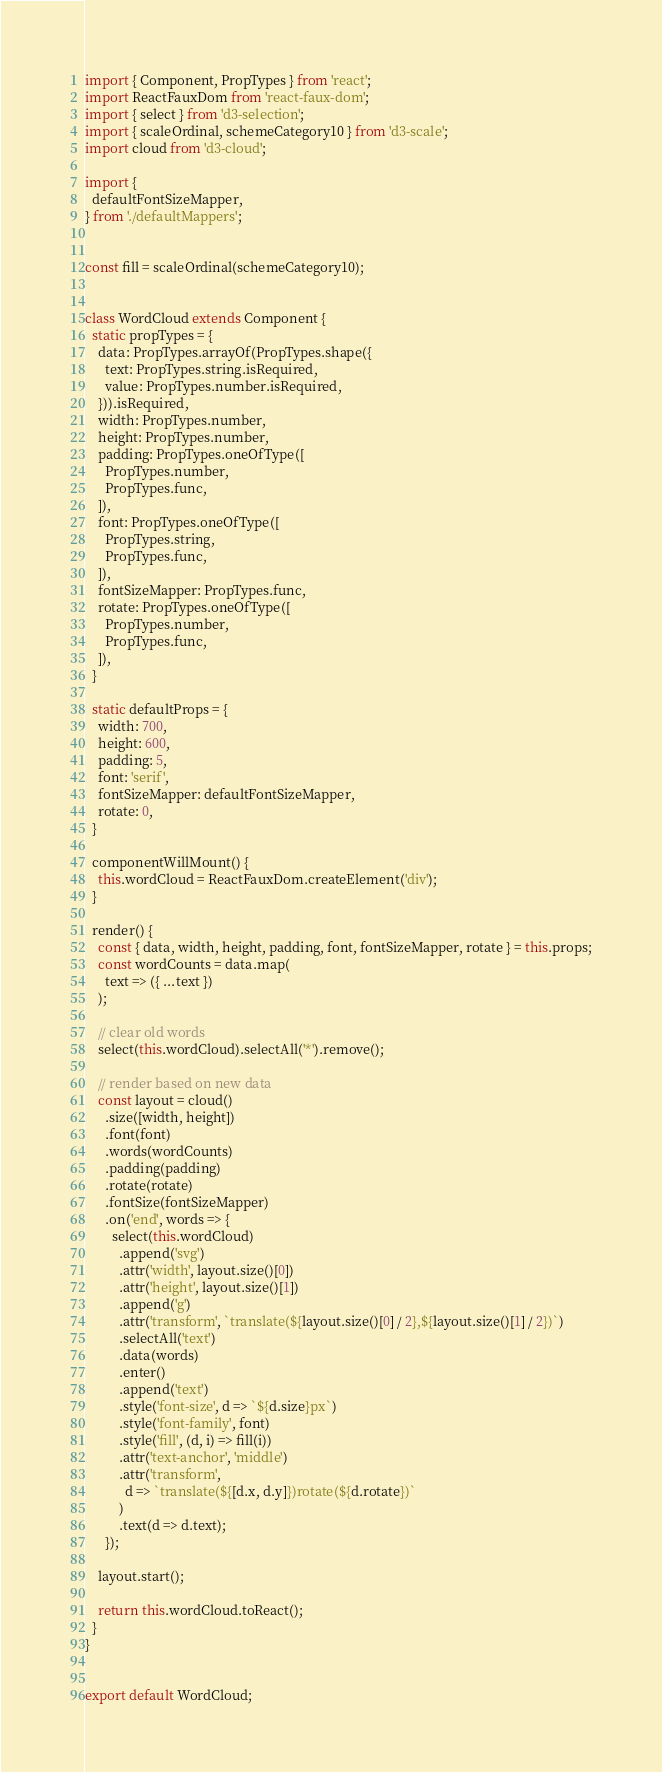<code> <loc_0><loc_0><loc_500><loc_500><_JavaScript_>import { Component, PropTypes } from 'react';
import ReactFauxDom from 'react-faux-dom';
import { select } from 'd3-selection';
import { scaleOrdinal, schemeCategory10 } from 'd3-scale';
import cloud from 'd3-cloud';

import {
  defaultFontSizeMapper,
} from './defaultMappers';


const fill = scaleOrdinal(schemeCategory10);


class WordCloud extends Component {
  static propTypes = {
    data: PropTypes.arrayOf(PropTypes.shape({
      text: PropTypes.string.isRequired,
      value: PropTypes.number.isRequired,
    })).isRequired,
    width: PropTypes.number,
    height: PropTypes.number,
    padding: PropTypes.oneOfType([
      PropTypes.number,
      PropTypes.func,
    ]),
    font: PropTypes.oneOfType([
      PropTypes.string,
      PropTypes.func,
    ]),
    fontSizeMapper: PropTypes.func,
    rotate: PropTypes.oneOfType([
      PropTypes.number,
      PropTypes.func,
    ]),
  }

  static defaultProps = {
    width: 700,
    height: 600,
    padding: 5,
    font: 'serif',
    fontSizeMapper: defaultFontSizeMapper,
    rotate: 0,
  }

  componentWillMount() {
    this.wordCloud = ReactFauxDom.createElement('div');
  }

  render() {
    const { data, width, height, padding, font, fontSizeMapper, rotate } = this.props;
    const wordCounts = data.map(
      text => ({ ...text })
    );

    // clear old words
    select(this.wordCloud).selectAll('*').remove();

    // render based on new data
    const layout = cloud()
      .size([width, height])
      .font(font)
      .words(wordCounts)
      .padding(padding)
      .rotate(rotate)
      .fontSize(fontSizeMapper)
      .on('end', words => {
        select(this.wordCloud)
          .append('svg')
          .attr('width', layout.size()[0])
          .attr('height', layout.size()[1])
          .append('g')
          .attr('transform', `translate(${layout.size()[0] / 2},${layout.size()[1] / 2})`)
          .selectAll('text')
          .data(words)
          .enter()
          .append('text')
          .style('font-size', d => `${d.size}px`)
          .style('font-family', font)
          .style('fill', (d, i) => fill(i))
          .attr('text-anchor', 'middle')
          .attr('transform',
            d => `translate(${[d.x, d.y]})rotate(${d.rotate})`
          )
          .text(d => d.text);
      });

    layout.start();

    return this.wordCloud.toReact();
  }
}


export default WordCloud;
</code> 